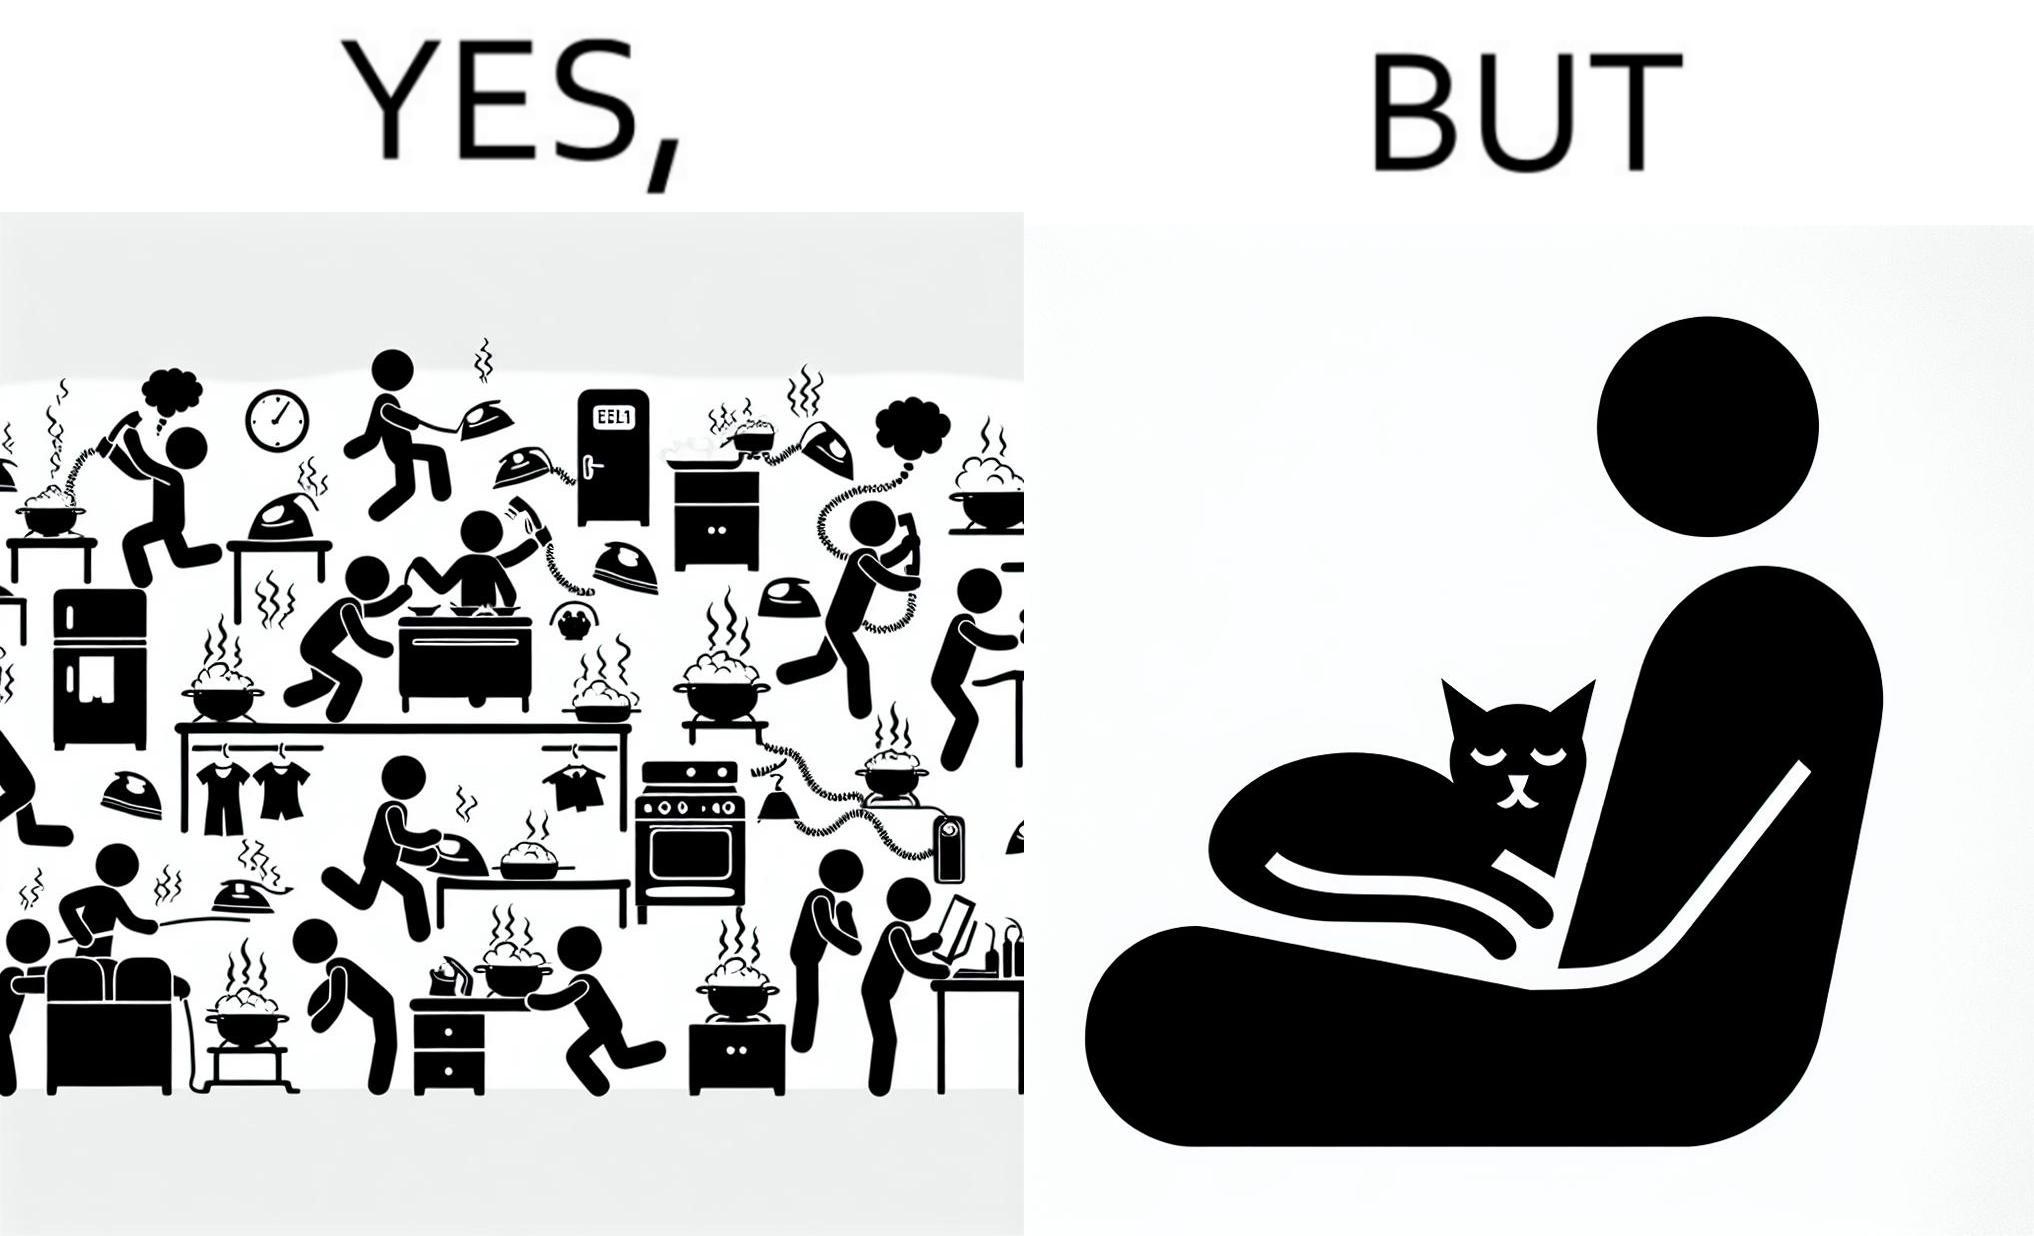Provide a description of this image. the irony in this image is that people ignore all the chaos around them and get distracted by a cat. 